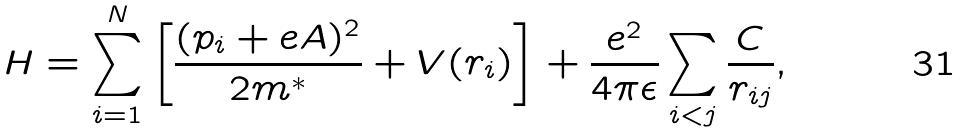Convert formula to latex. <formula><loc_0><loc_0><loc_500><loc_500>H = \sum ^ { N } _ { i = 1 } \left [ \frac { ( { p } _ { i } + e { A } ) ^ { 2 } } { 2 m ^ { * } } + V ( r _ { i } ) \right ] + \frac { e ^ { 2 } } { 4 \pi \epsilon } \sum _ { i < j } \frac { C } { r _ { i j } } ,</formula> 